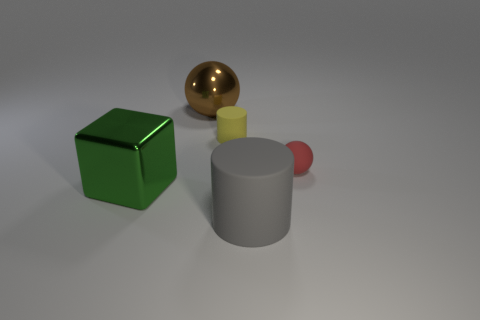What is the cube made of?
Ensure brevity in your answer.  Metal. How many large brown shiny things have the same shape as the red rubber object?
Provide a succinct answer. 1. Is there any other thing that is the same shape as the green metal object?
Offer a terse response. No. The cylinder to the right of the rubber thing behind the rubber object to the right of the gray matte cylinder is what color?
Provide a short and direct response. Gray. What number of big objects are either rubber spheres or red metallic cylinders?
Provide a succinct answer. 0. Are there an equal number of yellow things on the left side of the tiny yellow object and big cylinders?
Your response must be concise. No. Are there any big metallic balls in front of the yellow matte object?
Ensure brevity in your answer.  No. What number of metallic things are either balls or small cylinders?
Ensure brevity in your answer.  1. How many big things are in front of the shiny ball?
Keep it short and to the point. 2. Is there a yellow object that has the same size as the rubber sphere?
Your answer should be very brief. Yes. 